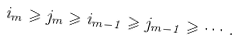Convert formula to latex. <formula><loc_0><loc_0><loc_500><loc_500>i _ { m } \geqslant j _ { m } \geqslant i _ { m - 1 } \geqslant j _ { m - 1 } \geqslant \cdots .</formula> 